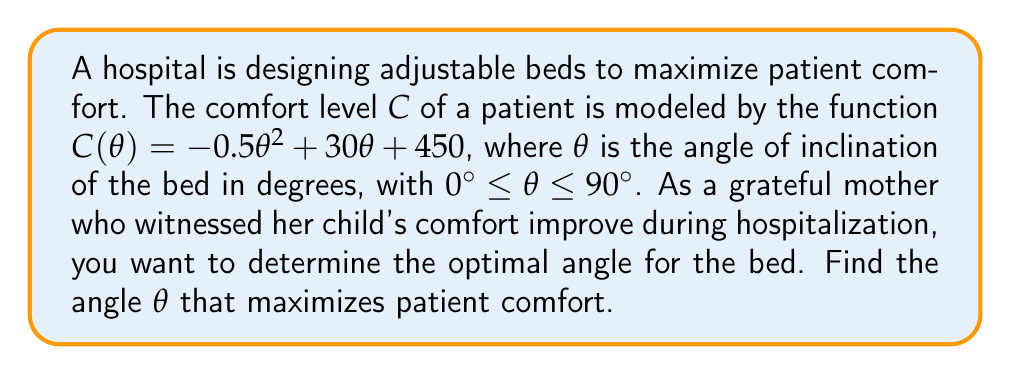What is the answer to this math problem? To find the optimal angle that maximizes patient comfort, we need to follow these steps:

1) The comfort level function is given by:
   $$C(\theta) = -0.5\theta^2 + 30\theta + 450$$

2) To find the maximum, we need to find where the derivative of $C(\theta)$ equals zero:
   $$\frac{dC}{d\theta} = -\theta + 30$$

3) Set the derivative equal to zero and solve for $\theta$:
   $$-\theta + 30 = 0$$
   $$\theta = 30$$

4) To confirm this is a maximum (not a minimum), we can check the second derivative:
   $$\frac{d^2C}{d\theta^2} = -1$$

   Since the second derivative is negative, this confirms that $\theta = 30°$ gives a maximum.

5) We also need to check the endpoints of our interval $[0°, 90°]$:
   $$C(0°) = 450$$
   $$C(30°) = -0.5(30)^2 + 30(30) + 450 = 900$$
   $$C(90°) = -0.5(90)^2 + 30(90) + 450 = 450$$

6) The maximum value occurs at $\theta = 30°$, which is within our interval and greater than the values at the endpoints.

Therefore, the optimal angle for maximizing patient comfort is 30°.
Answer: $30°$ 